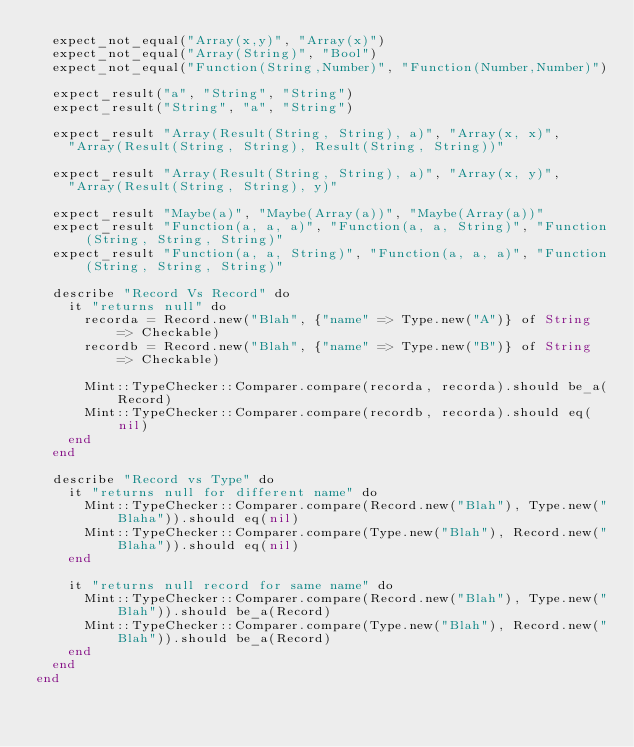Convert code to text. <code><loc_0><loc_0><loc_500><loc_500><_Crystal_>  expect_not_equal("Array(x,y)", "Array(x)")
  expect_not_equal("Array(String)", "Bool")
  expect_not_equal("Function(String,Number)", "Function(Number,Number)")

  expect_result("a", "String", "String")
  expect_result("String", "a", "String")

  expect_result "Array(Result(String, String), a)", "Array(x, x)",
    "Array(Result(String, String), Result(String, String))"

  expect_result "Array(Result(String, String), a)", "Array(x, y)",
    "Array(Result(String, String), y)"

  expect_result "Maybe(a)", "Maybe(Array(a))", "Maybe(Array(a))"
  expect_result "Function(a, a, a)", "Function(a, a, String)", "Function(String, String, String)"
  expect_result "Function(a, a, String)", "Function(a, a, a)", "Function(String, String, String)"

  describe "Record Vs Record" do
    it "returns null" do
      recorda = Record.new("Blah", {"name" => Type.new("A")} of String => Checkable)
      recordb = Record.new("Blah", {"name" => Type.new("B")} of String => Checkable)

      Mint::TypeChecker::Comparer.compare(recorda, recorda).should be_a(Record)
      Mint::TypeChecker::Comparer.compare(recordb, recorda).should eq(nil)
    end
  end

  describe "Record vs Type" do
    it "returns null for different name" do
      Mint::TypeChecker::Comparer.compare(Record.new("Blah"), Type.new("Blaha")).should eq(nil)
      Mint::TypeChecker::Comparer.compare(Type.new("Blah"), Record.new("Blaha")).should eq(nil)
    end

    it "returns null record for same name" do
      Mint::TypeChecker::Comparer.compare(Record.new("Blah"), Type.new("Blah")).should be_a(Record)
      Mint::TypeChecker::Comparer.compare(Type.new("Blah"), Record.new("Blah")).should be_a(Record)
    end
  end
end
</code> 